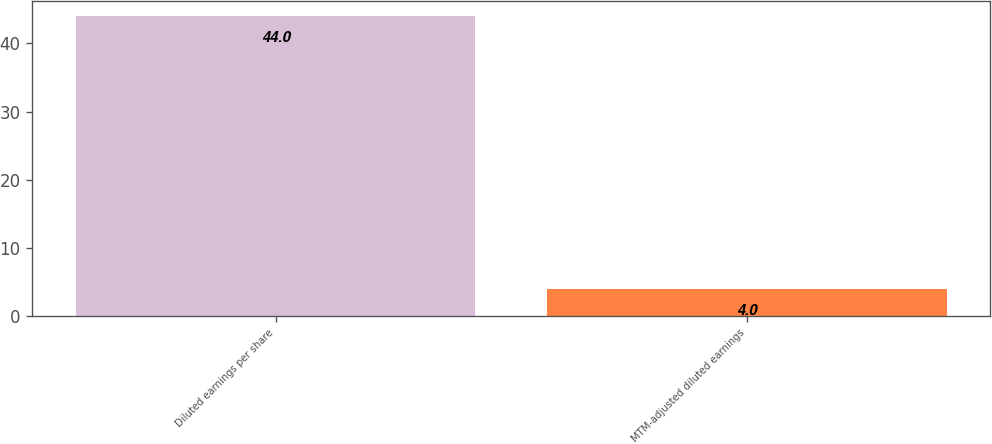<chart> <loc_0><loc_0><loc_500><loc_500><bar_chart><fcel>Diluted earnings per share<fcel>MTM-adjusted diluted earnings<nl><fcel>44<fcel>4<nl></chart> 